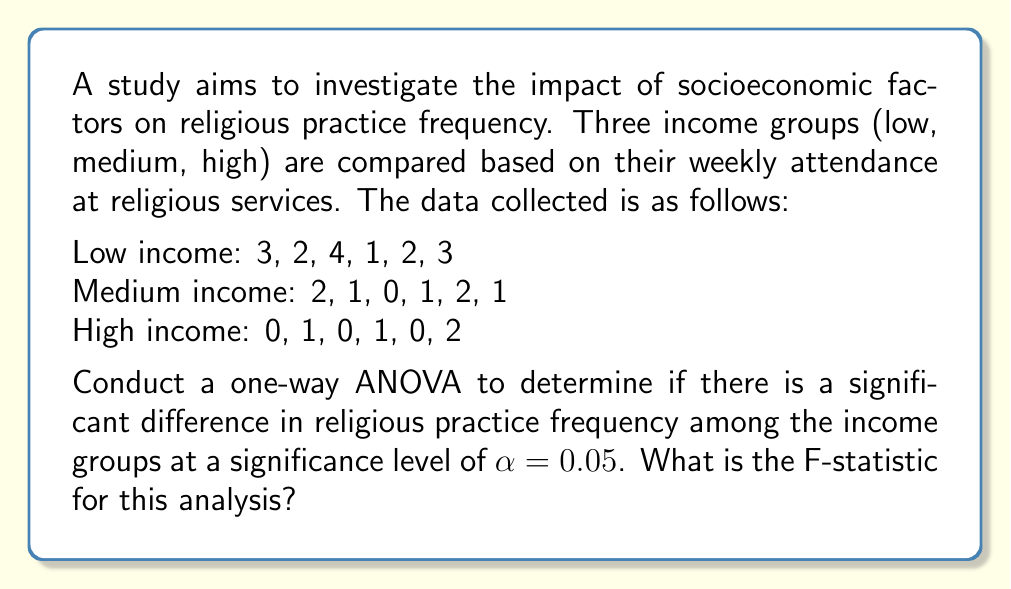Could you help me with this problem? To conduct a one-way ANOVA, we need to follow these steps:

1. Calculate the group means and overall mean:
   Low income mean: $\bar{X}_1 = \frac{3 + 2 + 4 + 1 + 2 + 3}{6} = 2.5$
   Medium income mean: $\bar{X}_2 = \frac{2 + 1 + 0 + 1 + 2 + 1}{6} = 1.167$
   High income mean: $\bar{X}_3 = \frac{0 + 1 + 0 + 1 + 0 + 2}{6} = 0.667$
   Overall mean: $\bar{X} = \frac{2.5 + 1.167 + 0.667}{3} = 1.445$

2. Calculate the Sum of Squares Between groups (SSB):
   $$SSB = \sum_{i=1}^{k} n_i(\bar{X}_i - \bar{X})^2$$
   $$SSB = 6(2.5 - 1.445)^2 + 6(1.167 - 1.445)^2 + 6(0.667 - 1.445)^2 = 11.343$$

3. Calculate the Sum of Squares Within groups (SSW):
   $$SSW = \sum_{i=1}^{k} \sum_{j=1}^{n_i} (X_{ij} - \bar{X}_i)^2$$
   $$SSW = [(3-2.5)^2 + (2-2.5)^2 + (4-2.5)^2 + (1-2.5)^2 + (2-2.5)^2 + (3-2.5)^2] +$$
   $$[(2-1.167)^2 + (1-1.167)^2 + (0-1.167)^2 + (1-1.167)^2 + (2-1.167)^2 + (1-1.167)^2] +$$
   $$[(0-0.667)^2 + (1-0.667)^2 + (0-0.667)^2 + (1-0.667)^2 + (0-0.667)^2 + (2-0.667)^2]$$
   $$SSW = 7.5 + 3.833 + 3.333 = 14.666$$

4. Calculate the degrees of freedom:
   Between groups: $df_B = k - 1 = 3 - 1 = 2$
   Within groups: $df_W = N - k = 18 - 3 = 15$

5. Calculate the Mean Square Between (MSB) and Mean Square Within (MSW):
   $$MSB = \frac{SSB}{df_B} = \frac{11.343}{2} = 5.672$$
   $$MSW = \frac{SSW}{df_W} = \frac{14.666}{15} = 0.978$$

6. Calculate the F-statistic:
   $$F = \frac{MSB}{MSW} = \frac{5.672}{0.978} = 5.802$$
Answer: The F-statistic for this one-way ANOVA is 5.802. 